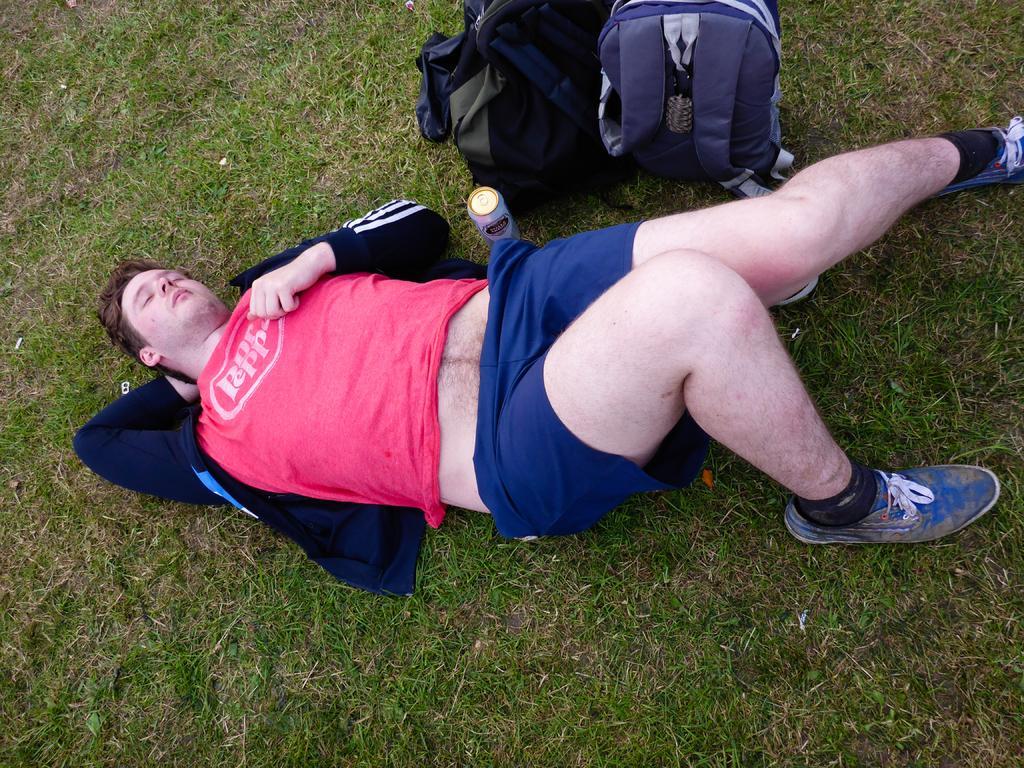Describe this image in one or two sentences. In this image there is a person lying on the grass, beside the person there is a can and two bags. 